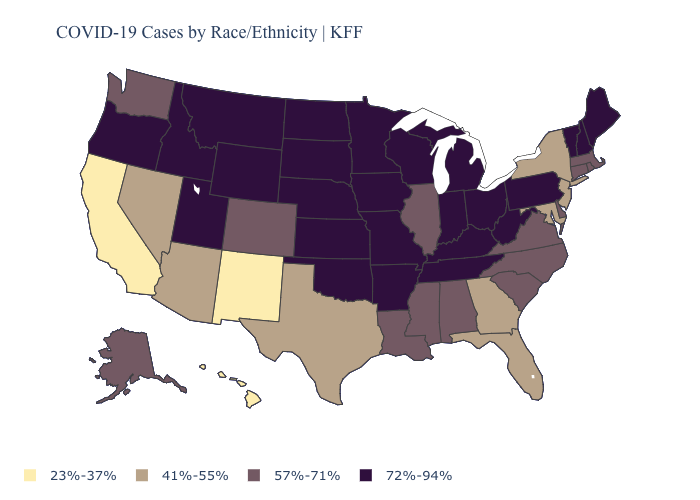Which states have the lowest value in the USA?
Answer briefly. California, Hawaii, New Mexico. What is the value of Kentucky?
Short answer required. 72%-94%. Name the states that have a value in the range 23%-37%?
Give a very brief answer. California, Hawaii, New Mexico. What is the value of Rhode Island?
Concise answer only. 57%-71%. Name the states that have a value in the range 57%-71%?
Write a very short answer. Alabama, Alaska, Colorado, Connecticut, Delaware, Illinois, Louisiana, Massachusetts, Mississippi, North Carolina, Rhode Island, South Carolina, Virginia, Washington. Which states have the highest value in the USA?
Give a very brief answer. Arkansas, Idaho, Indiana, Iowa, Kansas, Kentucky, Maine, Michigan, Minnesota, Missouri, Montana, Nebraska, New Hampshire, North Dakota, Ohio, Oklahoma, Oregon, Pennsylvania, South Dakota, Tennessee, Utah, Vermont, West Virginia, Wisconsin, Wyoming. What is the value of Delaware?
Keep it brief. 57%-71%. Does Indiana have the highest value in the MidWest?
Be succinct. Yes. What is the lowest value in states that border Pennsylvania?
Short answer required. 41%-55%. What is the lowest value in states that border Missouri?
Quick response, please. 57%-71%. What is the highest value in states that border New Mexico?
Answer briefly. 72%-94%. Does the map have missing data?
Keep it brief. No. Is the legend a continuous bar?
Concise answer only. No. Does the first symbol in the legend represent the smallest category?
Answer briefly. Yes. Name the states that have a value in the range 23%-37%?
Give a very brief answer. California, Hawaii, New Mexico. 